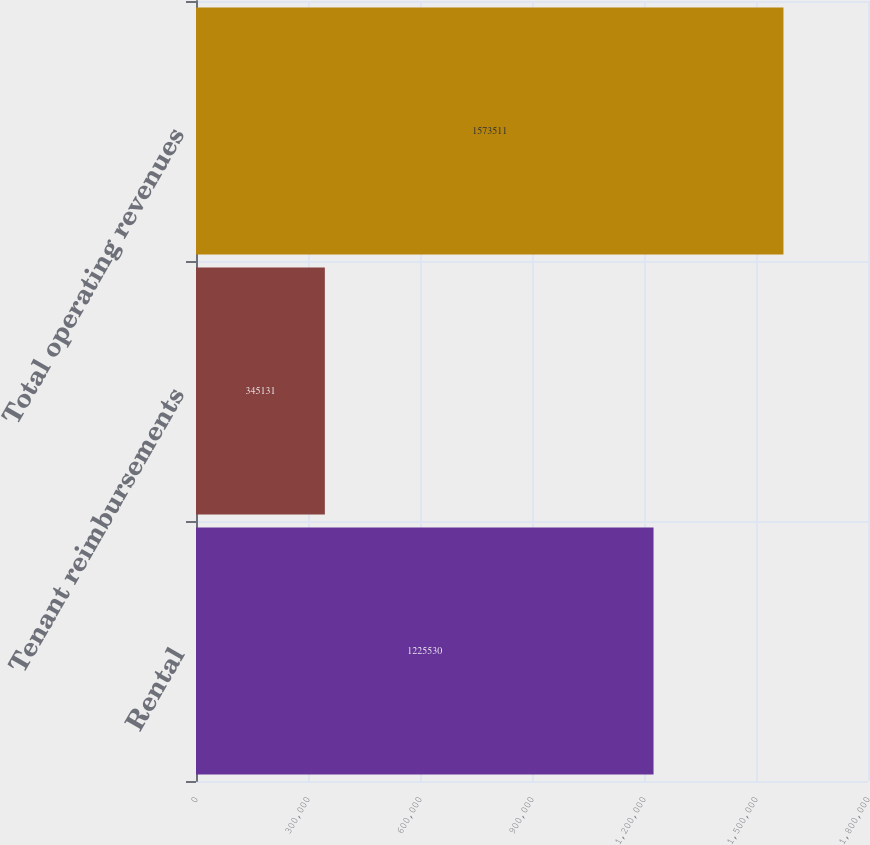<chart> <loc_0><loc_0><loc_500><loc_500><bar_chart><fcel>Rental<fcel>Tenant reimbursements<fcel>Total operating revenues<nl><fcel>1.22553e+06<fcel>345131<fcel>1.57351e+06<nl></chart> 